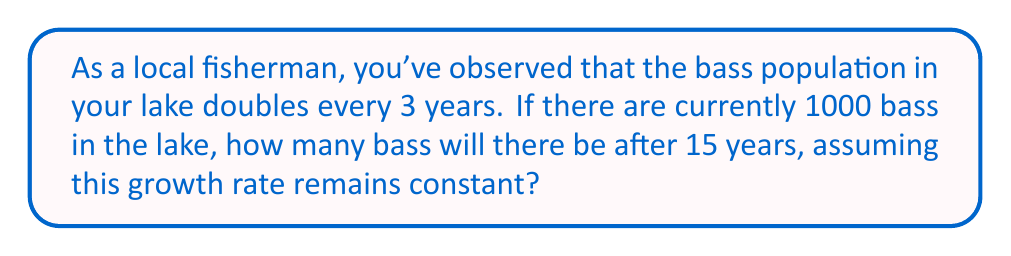Help me with this question. Let's approach this step-by-step:

1) We're dealing with exponential growth. The general formula for exponential growth is:

   $A = P(1 + r)^t$

   Where:
   $A$ = Final amount
   $P$ = Initial amount
   $r$ = Growth rate
   $t$ = Time periods

2) In this case:
   $P = 1000$ (initial bass population)
   $t = 15$ years

3) We need to find $r$. We know the population doubles every 3 years. This means:

   $2 = (1 + r)^3$

4) Solving for $r$:
   $\sqrt[3]{2} = 1 + r$
   $r = \sqrt[3]{2} - 1 \approx 0.2599$ or about 26% per year

5) Now, we need to adjust our time periods. Since the growth rate is per year, but the doubling occurs every 3 years, we'll use 15 years in our calculation.

6) Plugging into our formula:

   $A = 1000(1 + 0.2599)^{15}$

7) Calculating:
   $A = 1000(1.2599)^{15} \approx 32000$

Therefore, after 15 years, there will be approximately 32,000 bass in the lake.
Answer: 32,000 bass 